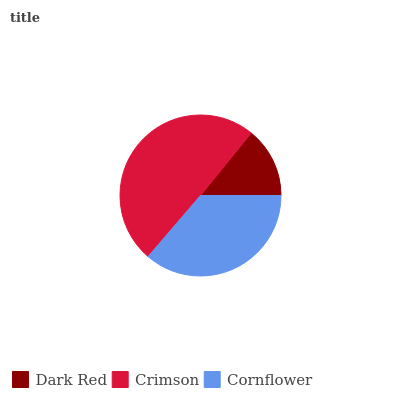Is Dark Red the minimum?
Answer yes or no. Yes. Is Crimson the maximum?
Answer yes or no. Yes. Is Cornflower the minimum?
Answer yes or no. No. Is Cornflower the maximum?
Answer yes or no. No. Is Crimson greater than Cornflower?
Answer yes or no. Yes. Is Cornflower less than Crimson?
Answer yes or no. Yes. Is Cornflower greater than Crimson?
Answer yes or no. No. Is Crimson less than Cornflower?
Answer yes or no. No. Is Cornflower the high median?
Answer yes or no. Yes. Is Cornflower the low median?
Answer yes or no. Yes. Is Dark Red the high median?
Answer yes or no. No. Is Crimson the low median?
Answer yes or no. No. 